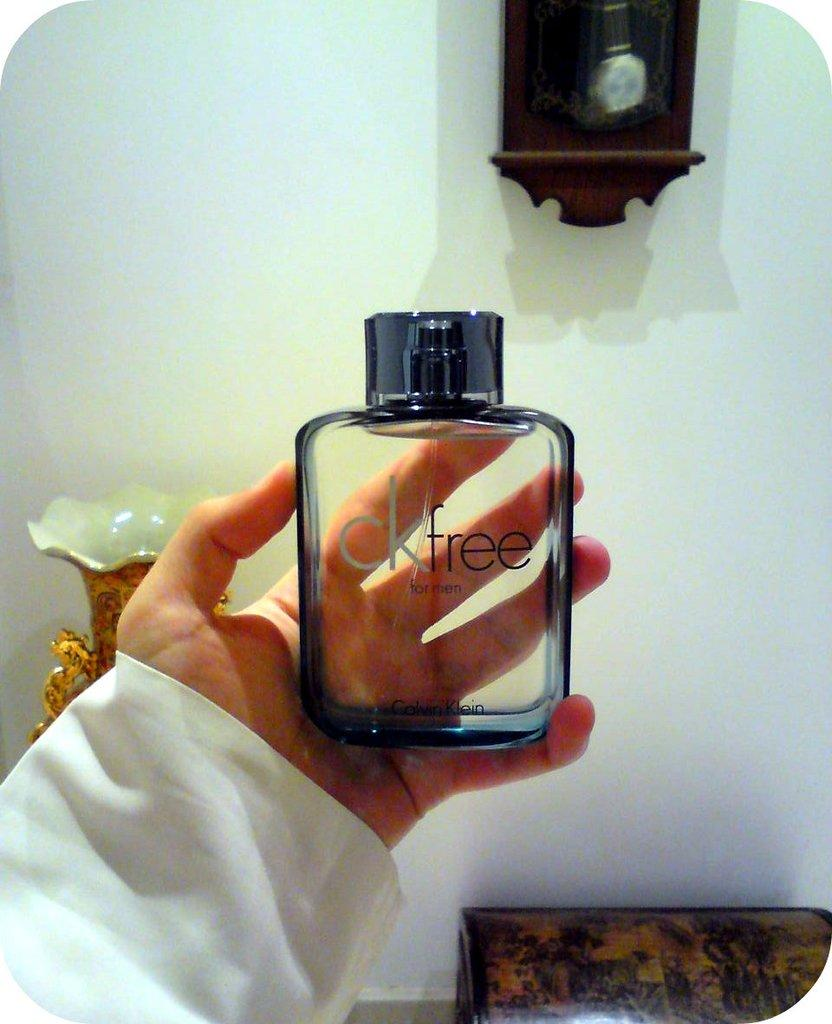<image>
Describe the image concisely. A bottle of calvin klein that someone is holding 